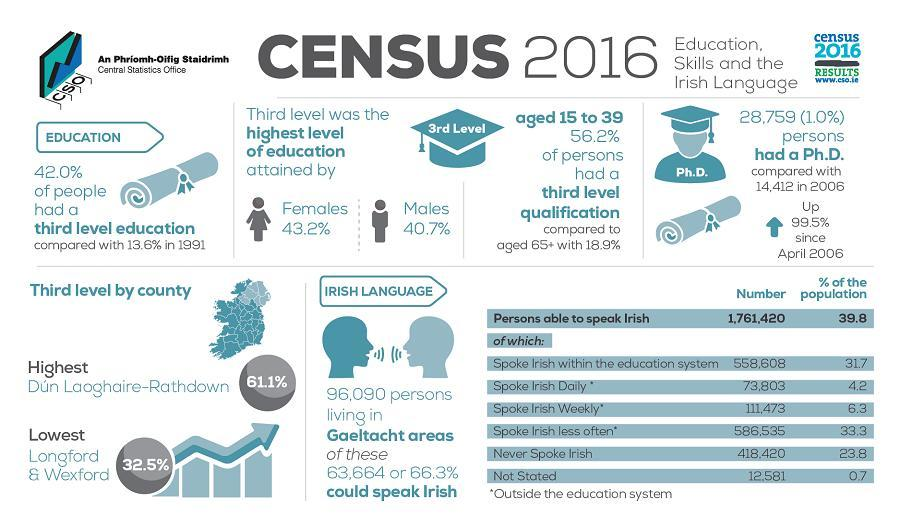What is the percentage of females?
Answer the question with a short phrase. 43.2% What is the percentage of males? 40.7% 